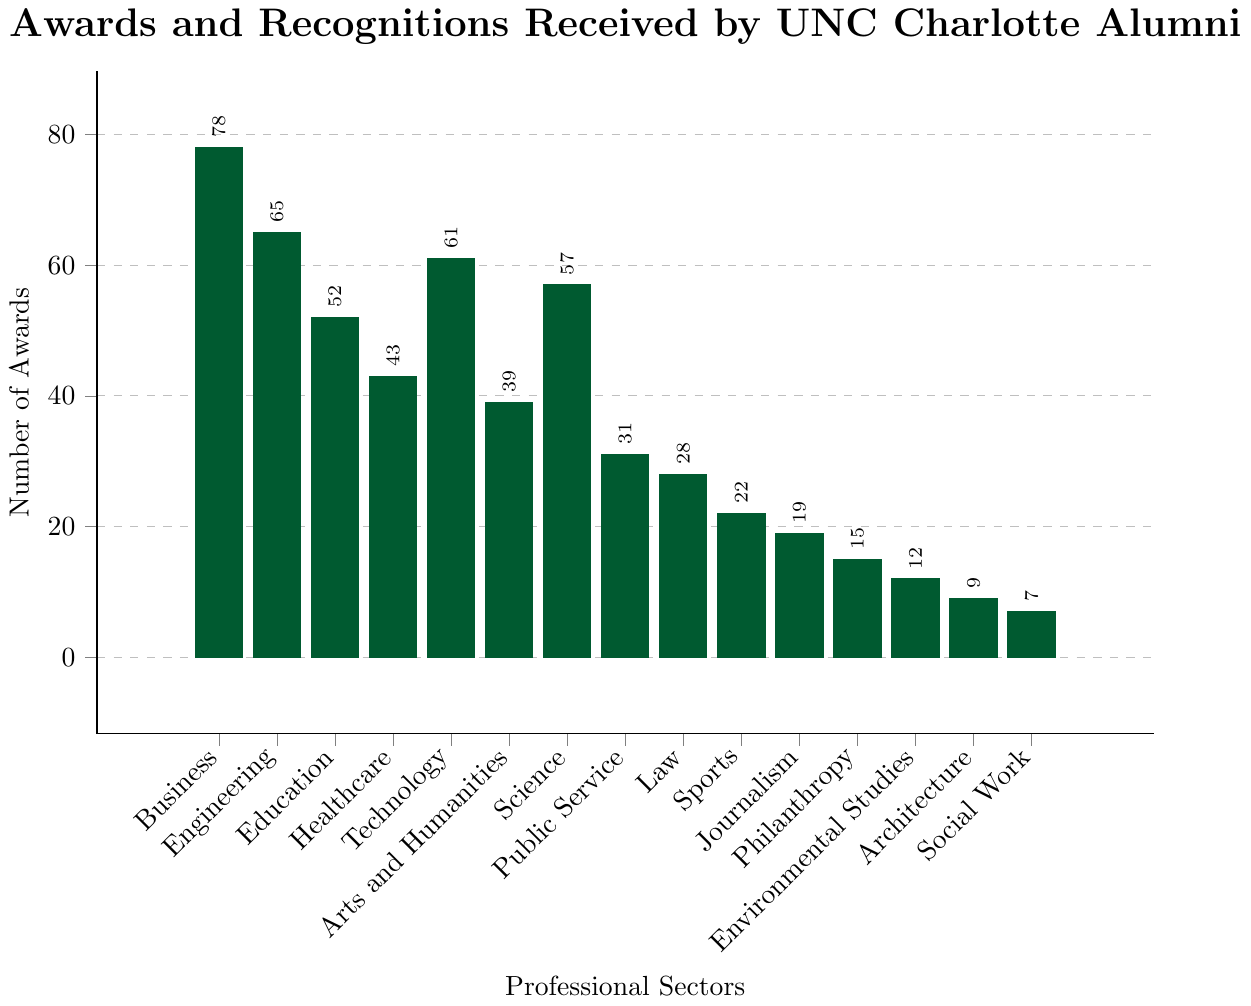Which sector received the highest number of awards? The highest bar in the bar chart corresponds to the sector with the most awards. The Business sector has the highest bar.
Answer: Business What's the total number of awards received by alumni in Technology and Engineering? Add the number of awards for Technology (61) and Engineering (65). 61 + 65 = 126
Answer: 126 How many more awards did the Business sector receive compared to the Social Work sector? Subtract the number of awards in the Social Work sector (7) from the number of awards in the Business sector (78). 78 - 7 = 71
Answer: 71 Among Healthcare, Education, and Science, which sector has the fewest awards? Compare the number of awards in these sectors: Healthcare (43), Education (52), and Science (57). Healthcare has the fewest awards.
Answer: Healthcare What is the average number of awards received by Public Service, Law, and Sports sectors? Add the number of awards in these sectors: Public Service (31), Law (28), and Sports (22). The sum is 31 + 28 + 22 = 81. Divide by the number of sectors (3). 81 / 3 = 27
Answer: 27 What is the median value of the number of awards across all sectors? Sort the number of awards: [7, 9, 12, 15, 19, 22, 28, 31, 39, 43, 52, 57, 61, 65, 78]. The median is the middle value. The middle (8th) value is 31.
Answer: 31 How many sectors received fewer than 20 awards? Count the sectors with awards less than 20: Journalism (19), Philanthropy (15), Environmental Studies (12), Architecture (9), Social Work (7). There are 5 such sectors.
Answer: 5 Which two sectors have a combined total of 97 awards? Test combinations of two sectors to find the pair that sums to 97. Engineering (65) + Environmental Studies (12) = 77; Technology (61) + Architecture (9) = 70; Business (78) + Journalism (19) = 97
Answer: Business and Journalism How does the number of awards in Science compare to Technology? Science has 57 awards and Technology has 61 awards. Technology has more awards than Science.
Answer: Technology has more awards Which sector has the closest number of awards to the Arts and Humanities sector? Arts and Humanities has 39 awards. Compare with the awards in adjacent counts: Public Service (31) and Healthcare (43). Healthcare is the closest.
Answer: Healthcare 